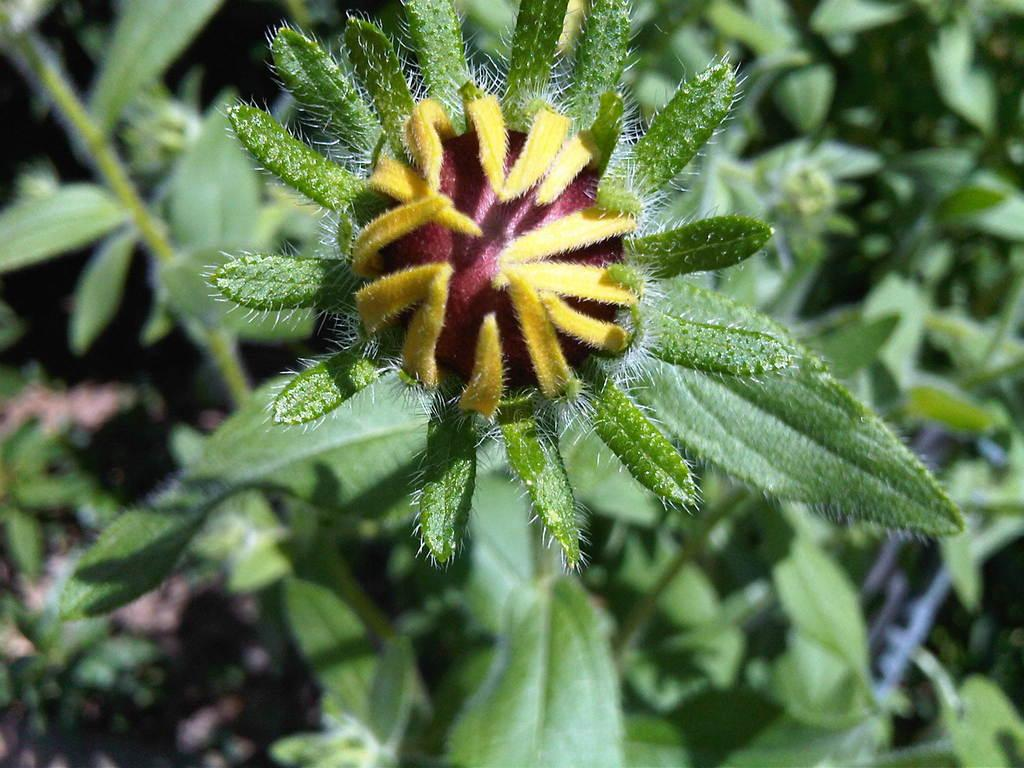What is the main subject of the image? There is a flower in the image. What can be seen in addition to the flower? There are green leaves in the image. What type of soup is being served in the mine in the image? There is no soup or mine present in the image; it features a flower and green leaves. 